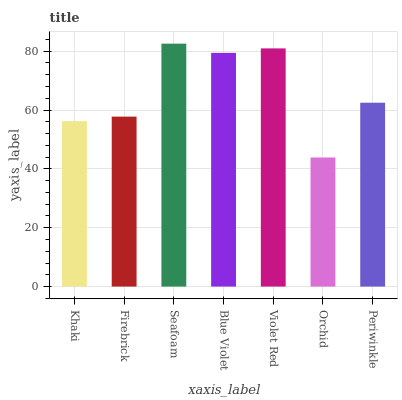Is Orchid the minimum?
Answer yes or no. Yes. Is Seafoam the maximum?
Answer yes or no. Yes. Is Firebrick the minimum?
Answer yes or no. No. Is Firebrick the maximum?
Answer yes or no. No. Is Firebrick greater than Khaki?
Answer yes or no. Yes. Is Khaki less than Firebrick?
Answer yes or no. Yes. Is Khaki greater than Firebrick?
Answer yes or no. No. Is Firebrick less than Khaki?
Answer yes or no. No. Is Periwinkle the high median?
Answer yes or no. Yes. Is Periwinkle the low median?
Answer yes or no. Yes. Is Blue Violet the high median?
Answer yes or no. No. Is Blue Violet the low median?
Answer yes or no. No. 